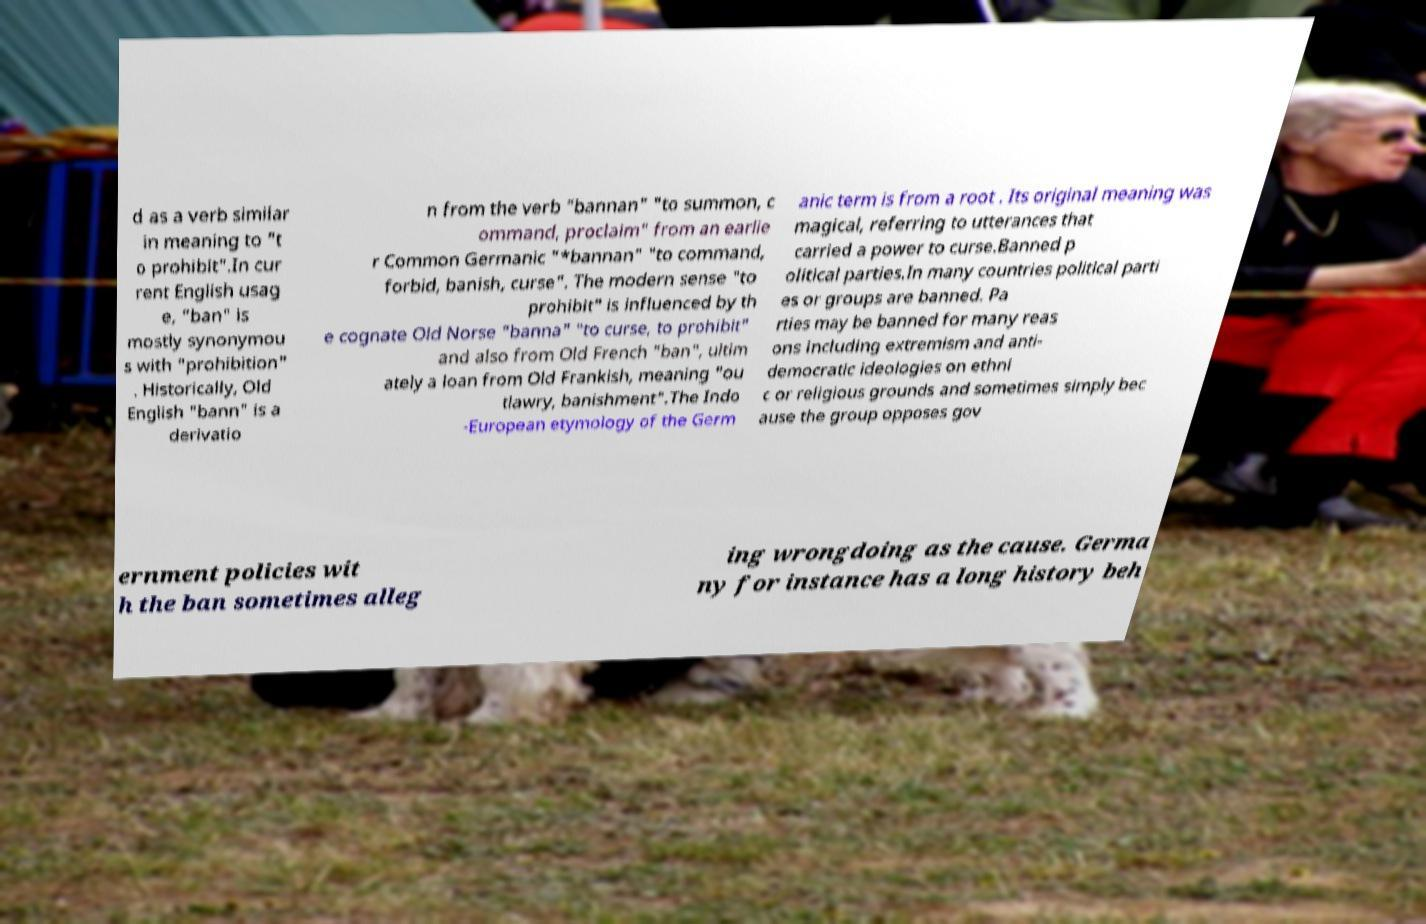I need the written content from this picture converted into text. Can you do that? d as a verb similar in meaning to "t o prohibit".In cur rent English usag e, "ban" is mostly synonymou s with "prohibition" . Historically, Old English "bann" is a derivatio n from the verb "bannan" "to summon, c ommand, proclaim" from an earlie r Common Germanic "*bannan" "to command, forbid, banish, curse". The modern sense "to prohibit" is influenced by th e cognate Old Norse "banna" "to curse, to prohibit" and also from Old French "ban", ultim ately a loan from Old Frankish, meaning "ou tlawry, banishment".The Indo -European etymology of the Germ anic term is from a root . Its original meaning was magical, referring to utterances that carried a power to curse.Banned p olitical parties.In many countries political parti es or groups are banned. Pa rties may be banned for many reas ons including extremism and anti- democratic ideologies on ethni c or religious grounds and sometimes simply bec ause the group opposes gov ernment policies wit h the ban sometimes alleg ing wrongdoing as the cause. Germa ny for instance has a long history beh 